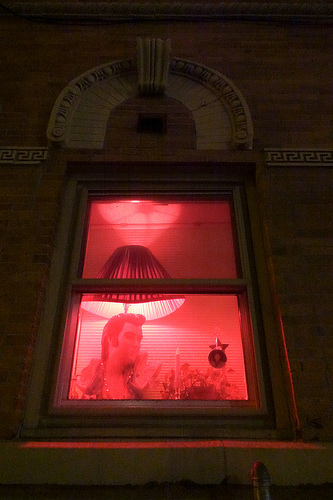<image>
Is the arch above the lamp? Yes. The arch is positioned above the lamp in the vertical space, higher up in the scene. 